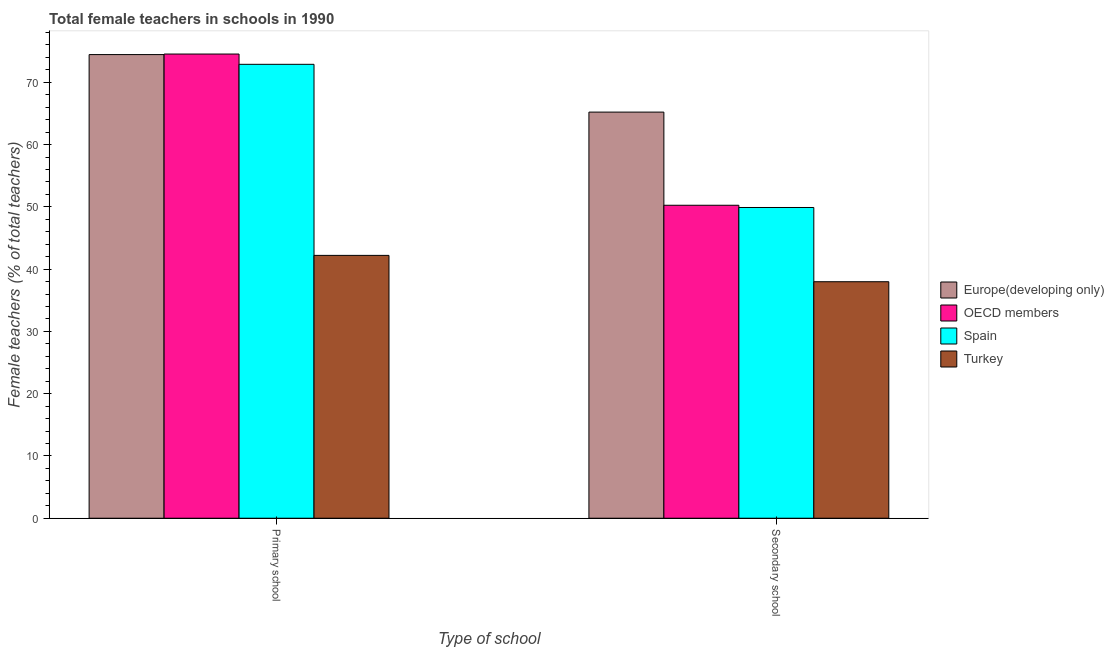How many different coloured bars are there?
Offer a very short reply. 4. Are the number of bars per tick equal to the number of legend labels?
Your answer should be compact. Yes. How many bars are there on the 1st tick from the left?
Your response must be concise. 4. How many bars are there on the 1st tick from the right?
Keep it short and to the point. 4. What is the label of the 2nd group of bars from the left?
Make the answer very short. Secondary school. What is the percentage of female teachers in primary schools in Spain?
Give a very brief answer. 72.88. Across all countries, what is the maximum percentage of female teachers in secondary schools?
Ensure brevity in your answer.  65.21. Across all countries, what is the minimum percentage of female teachers in secondary schools?
Your answer should be compact. 37.97. In which country was the percentage of female teachers in primary schools maximum?
Ensure brevity in your answer.  OECD members. What is the total percentage of female teachers in primary schools in the graph?
Offer a terse response. 264.06. What is the difference between the percentage of female teachers in secondary schools in Spain and that in Europe(developing only)?
Your answer should be very brief. -15.32. What is the difference between the percentage of female teachers in secondary schools in Turkey and the percentage of female teachers in primary schools in OECD members?
Offer a terse response. -36.56. What is the average percentage of female teachers in primary schools per country?
Make the answer very short. 66.02. What is the difference between the percentage of female teachers in secondary schools and percentage of female teachers in primary schools in Spain?
Give a very brief answer. -22.99. What is the ratio of the percentage of female teachers in secondary schools in OECD members to that in Spain?
Provide a short and direct response. 1.01. Is the percentage of female teachers in primary schools in Spain less than that in Turkey?
Offer a terse response. No. In how many countries, is the percentage of female teachers in primary schools greater than the average percentage of female teachers in primary schools taken over all countries?
Offer a very short reply. 3. How many bars are there?
Provide a succinct answer. 8. How many countries are there in the graph?
Offer a terse response. 4. What is the difference between two consecutive major ticks on the Y-axis?
Provide a succinct answer. 10. Does the graph contain any zero values?
Provide a short and direct response. No. What is the title of the graph?
Ensure brevity in your answer.  Total female teachers in schools in 1990. What is the label or title of the X-axis?
Ensure brevity in your answer.  Type of school. What is the label or title of the Y-axis?
Your response must be concise. Female teachers (% of total teachers). What is the Female teachers (% of total teachers) in Europe(developing only) in Primary school?
Offer a terse response. 74.44. What is the Female teachers (% of total teachers) of OECD members in Primary school?
Provide a short and direct response. 74.53. What is the Female teachers (% of total teachers) of Spain in Primary school?
Your answer should be compact. 72.88. What is the Female teachers (% of total teachers) of Turkey in Primary school?
Provide a short and direct response. 42.2. What is the Female teachers (% of total teachers) in Europe(developing only) in Secondary school?
Your response must be concise. 65.21. What is the Female teachers (% of total teachers) in OECD members in Secondary school?
Provide a short and direct response. 50.25. What is the Female teachers (% of total teachers) in Spain in Secondary school?
Give a very brief answer. 49.89. What is the Female teachers (% of total teachers) of Turkey in Secondary school?
Provide a succinct answer. 37.97. Across all Type of school, what is the maximum Female teachers (% of total teachers) in Europe(developing only)?
Your answer should be compact. 74.44. Across all Type of school, what is the maximum Female teachers (% of total teachers) in OECD members?
Make the answer very short. 74.53. Across all Type of school, what is the maximum Female teachers (% of total teachers) in Spain?
Ensure brevity in your answer.  72.88. Across all Type of school, what is the maximum Female teachers (% of total teachers) of Turkey?
Your response must be concise. 42.2. Across all Type of school, what is the minimum Female teachers (% of total teachers) of Europe(developing only)?
Your response must be concise. 65.21. Across all Type of school, what is the minimum Female teachers (% of total teachers) in OECD members?
Your response must be concise. 50.25. Across all Type of school, what is the minimum Female teachers (% of total teachers) of Spain?
Offer a terse response. 49.89. Across all Type of school, what is the minimum Female teachers (% of total teachers) in Turkey?
Make the answer very short. 37.97. What is the total Female teachers (% of total teachers) of Europe(developing only) in the graph?
Offer a very short reply. 139.65. What is the total Female teachers (% of total teachers) in OECD members in the graph?
Keep it short and to the point. 124.79. What is the total Female teachers (% of total teachers) in Spain in the graph?
Give a very brief answer. 122.77. What is the total Female teachers (% of total teachers) in Turkey in the graph?
Offer a terse response. 80.18. What is the difference between the Female teachers (% of total teachers) of Europe(developing only) in Primary school and that in Secondary school?
Offer a very short reply. 9.24. What is the difference between the Female teachers (% of total teachers) in OECD members in Primary school and that in Secondary school?
Keep it short and to the point. 24.28. What is the difference between the Female teachers (% of total teachers) in Spain in Primary school and that in Secondary school?
Offer a terse response. 22.99. What is the difference between the Female teachers (% of total teachers) of Turkey in Primary school and that in Secondary school?
Make the answer very short. 4.23. What is the difference between the Female teachers (% of total teachers) of Europe(developing only) in Primary school and the Female teachers (% of total teachers) of OECD members in Secondary school?
Offer a very short reply. 24.19. What is the difference between the Female teachers (% of total teachers) of Europe(developing only) in Primary school and the Female teachers (% of total teachers) of Spain in Secondary school?
Keep it short and to the point. 24.55. What is the difference between the Female teachers (% of total teachers) of Europe(developing only) in Primary school and the Female teachers (% of total teachers) of Turkey in Secondary school?
Ensure brevity in your answer.  36.47. What is the difference between the Female teachers (% of total teachers) in OECD members in Primary school and the Female teachers (% of total teachers) in Spain in Secondary school?
Your answer should be compact. 24.64. What is the difference between the Female teachers (% of total teachers) of OECD members in Primary school and the Female teachers (% of total teachers) of Turkey in Secondary school?
Offer a very short reply. 36.56. What is the difference between the Female teachers (% of total teachers) in Spain in Primary school and the Female teachers (% of total teachers) in Turkey in Secondary school?
Keep it short and to the point. 34.91. What is the average Female teachers (% of total teachers) in Europe(developing only) per Type of school?
Ensure brevity in your answer.  69.83. What is the average Female teachers (% of total teachers) in OECD members per Type of school?
Your response must be concise. 62.39. What is the average Female teachers (% of total teachers) in Spain per Type of school?
Make the answer very short. 61.39. What is the average Female teachers (% of total teachers) in Turkey per Type of school?
Your answer should be very brief. 40.09. What is the difference between the Female teachers (% of total teachers) in Europe(developing only) and Female teachers (% of total teachers) in OECD members in Primary school?
Your answer should be very brief. -0.09. What is the difference between the Female teachers (% of total teachers) of Europe(developing only) and Female teachers (% of total teachers) of Spain in Primary school?
Offer a very short reply. 1.56. What is the difference between the Female teachers (% of total teachers) of Europe(developing only) and Female teachers (% of total teachers) of Turkey in Primary school?
Offer a terse response. 32.24. What is the difference between the Female teachers (% of total teachers) of OECD members and Female teachers (% of total teachers) of Spain in Primary school?
Keep it short and to the point. 1.65. What is the difference between the Female teachers (% of total teachers) of OECD members and Female teachers (% of total teachers) of Turkey in Primary school?
Provide a succinct answer. 32.33. What is the difference between the Female teachers (% of total teachers) of Spain and Female teachers (% of total teachers) of Turkey in Primary school?
Offer a terse response. 30.68. What is the difference between the Female teachers (% of total teachers) in Europe(developing only) and Female teachers (% of total teachers) in OECD members in Secondary school?
Keep it short and to the point. 14.96. What is the difference between the Female teachers (% of total teachers) in Europe(developing only) and Female teachers (% of total teachers) in Spain in Secondary school?
Provide a short and direct response. 15.32. What is the difference between the Female teachers (% of total teachers) of Europe(developing only) and Female teachers (% of total teachers) of Turkey in Secondary school?
Give a very brief answer. 27.23. What is the difference between the Female teachers (% of total teachers) in OECD members and Female teachers (% of total teachers) in Spain in Secondary school?
Give a very brief answer. 0.36. What is the difference between the Female teachers (% of total teachers) of OECD members and Female teachers (% of total teachers) of Turkey in Secondary school?
Provide a succinct answer. 12.28. What is the difference between the Female teachers (% of total teachers) of Spain and Female teachers (% of total teachers) of Turkey in Secondary school?
Your answer should be very brief. 11.92. What is the ratio of the Female teachers (% of total teachers) of Europe(developing only) in Primary school to that in Secondary school?
Provide a short and direct response. 1.14. What is the ratio of the Female teachers (% of total teachers) of OECD members in Primary school to that in Secondary school?
Provide a short and direct response. 1.48. What is the ratio of the Female teachers (% of total teachers) of Spain in Primary school to that in Secondary school?
Make the answer very short. 1.46. What is the ratio of the Female teachers (% of total teachers) in Turkey in Primary school to that in Secondary school?
Offer a terse response. 1.11. What is the difference between the highest and the second highest Female teachers (% of total teachers) in Europe(developing only)?
Your answer should be very brief. 9.24. What is the difference between the highest and the second highest Female teachers (% of total teachers) of OECD members?
Provide a short and direct response. 24.28. What is the difference between the highest and the second highest Female teachers (% of total teachers) in Spain?
Keep it short and to the point. 22.99. What is the difference between the highest and the second highest Female teachers (% of total teachers) in Turkey?
Give a very brief answer. 4.23. What is the difference between the highest and the lowest Female teachers (% of total teachers) in Europe(developing only)?
Make the answer very short. 9.24. What is the difference between the highest and the lowest Female teachers (% of total teachers) in OECD members?
Ensure brevity in your answer.  24.28. What is the difference between the highest and the lowest Female teachers (% of total teachers) of Spain?
Provide a succinct answer. 22.99. What is the difference between the highest and the lowest Female teachers (% of total teachers) of Turkey?
Your answer should be very brief. 4.23. 